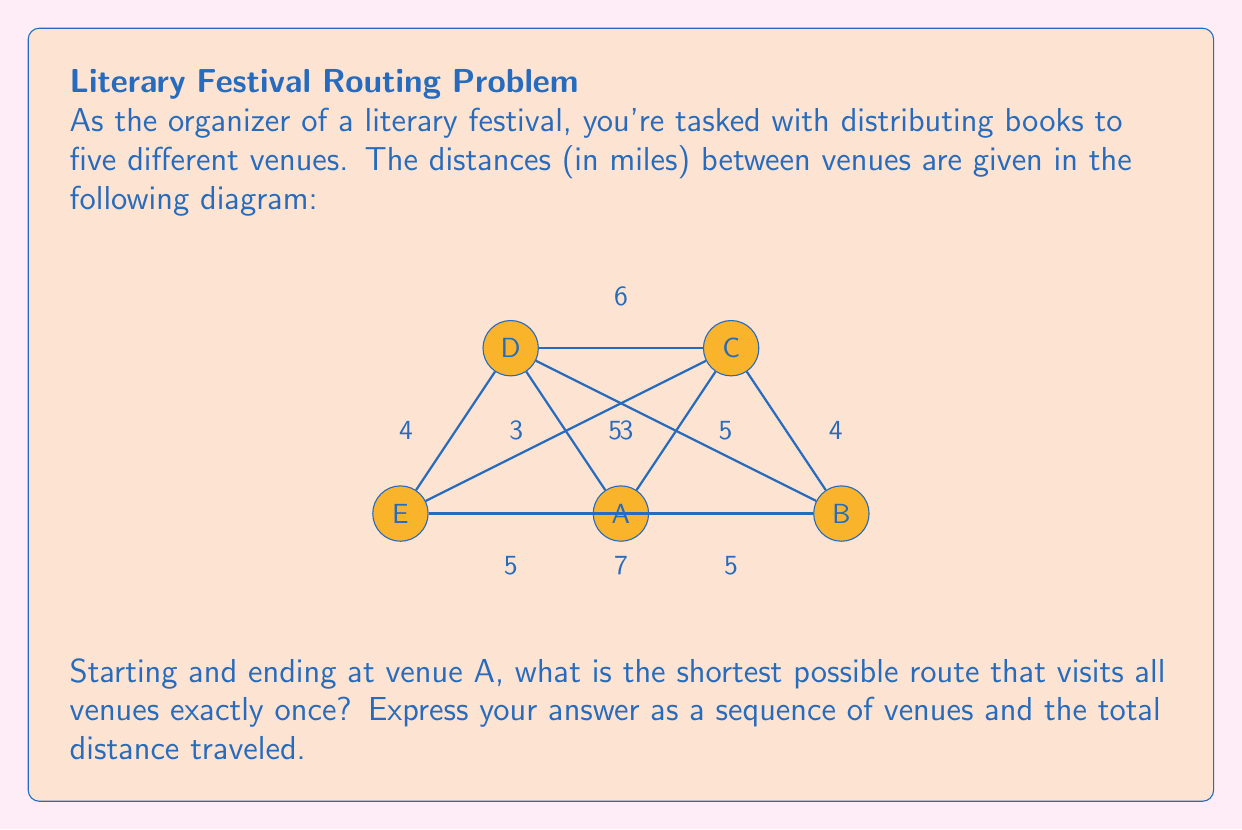Teach me how to tackle this problem. To solve this problem, we'll use the concept of the Traveling Salesman Problem (TSP) from Operations Research. Given the small number of venues, we can use a brute-force approach to find the optimal solution.

Step 1: List all possible routes starting and ending at A.
There are $(5-1)! = 24$ possible routes.

Step 2: Calculate the distance for each route.
Let's consider a few examples:

1. A-B-C-D-E-A: $5 + 4 + 6 + 4 + 5 = 24$ miles
2. A-B-E-D-C-A: $5 + 7 + 4 + 6 + 3 = 25$ miles
3. A-C-B-E-D-A: $3 + 4 + 7 + 4 + 3 = 21$ miles

Step 3: Identify the shortest route.
After calculating all 24 routes, we find that the shortest route is:

A-C-B-E-D-A with a total distance of 21 miles.

Step 4: Verify the solution.
Let's break down the chosen route:
- A to C: 3 miles
- C to B: 4 miles
- B to E: 7 miles
- E to D: 4 miles
- D to A: 3 miles

Total: $3 + 4 + 7 + 4 + 3 = 21$ miles

This route visits each venue exactly once and returns to the starting point A, satisfying all requirements of the problem.
Answer: A-C-B-E-D-A, 21 miles 